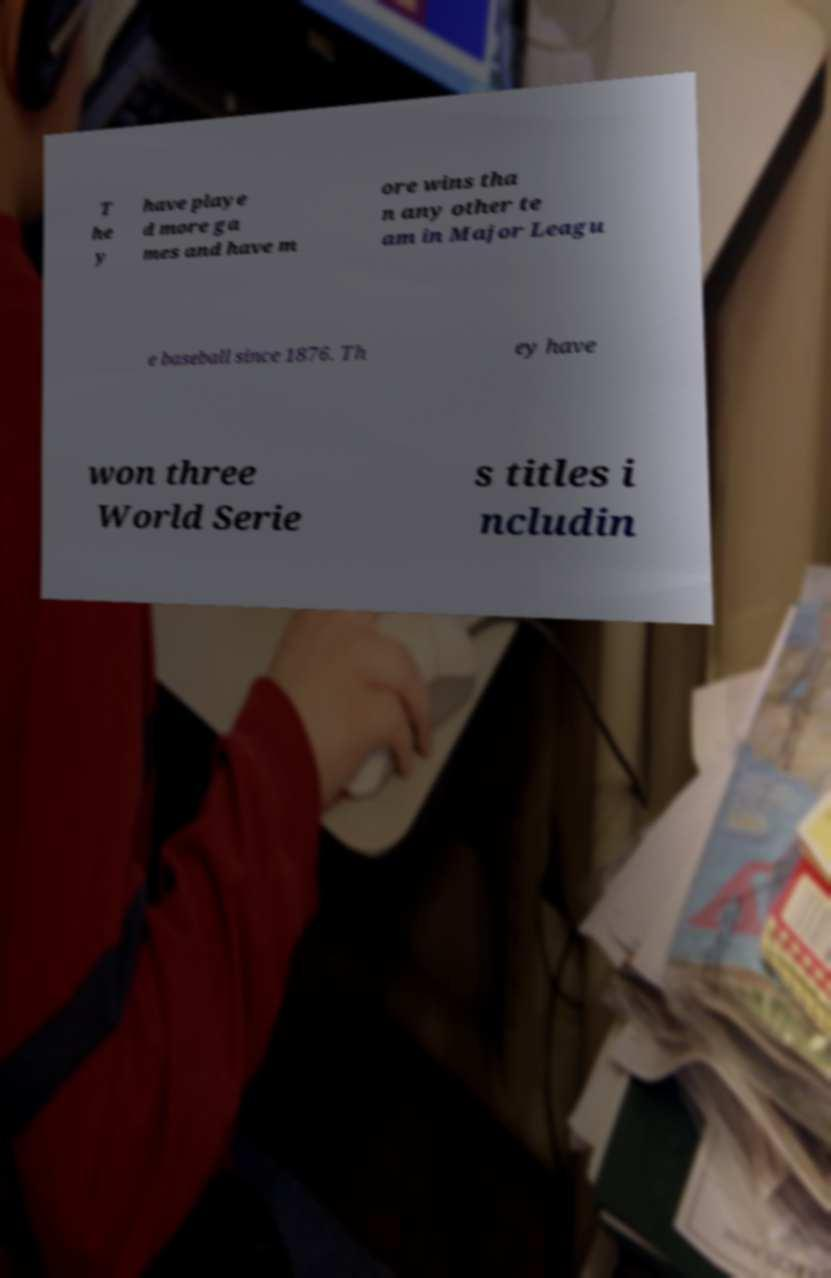Please read and relay the text visible in this image. What does it say? T he y have playe d more ga mes and have m ore wins tha n any other te am in Major Leagu e baseball since 1876. Th ey have won three World Serie s titles i ncludin 